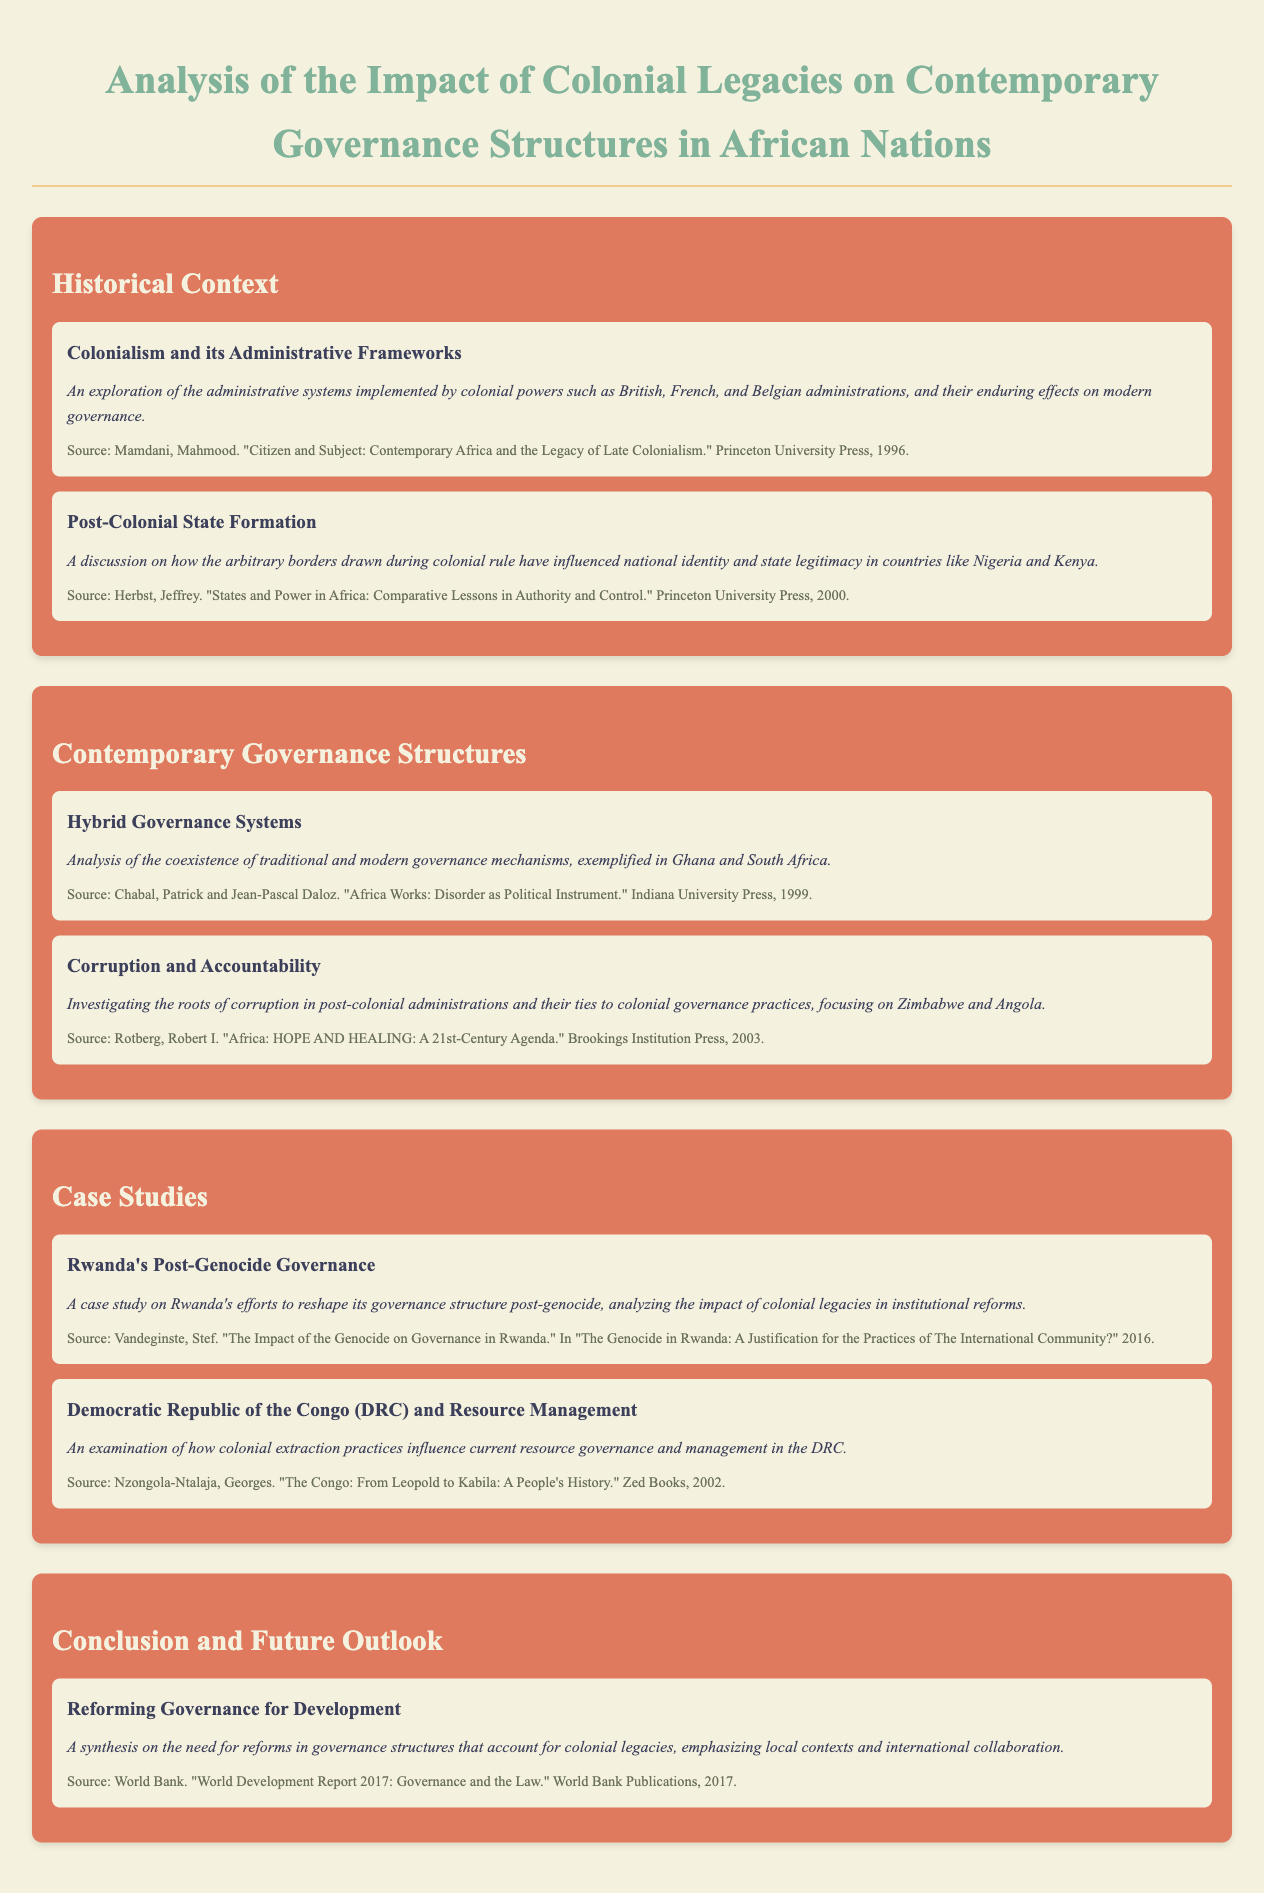What is the title of the document? The title appears prominently at the top of the document and is "Analysis of the Impact of Colonial Legacies on Contemporary Governance Structures in African Nations."
Answer: Analysis of the Impact of Colonial Legacies on Contemporary Governance Structures in African Nations Who authored "Citizen and Subject"? This work by Mahmood Mamdani discusses the enduring effects of colonial administrative systems.
Answer: Mahmood Mamdani Which country is specifically mentioned in the context of post-colonial state formation? The document discusses how arbitrary borders have influenced national identity in countries, specifically mentioning Nigeria and Kenya.
Answer: Nigeria and Kenya What is the main focus of the case study on Rwanda? The document details Rwanda's efforts to reshape governance post-genocide, analyzing colonial legacies in institutional reforms.
Answer: Rwanda's Post-Genocide Governance What type of governance systems are examined in Ghana and South Africa? The document analyzes the coexistence of traditional and modern governance mechanisms in these countries.
Answer: Hybrid Governance Systems What significant issue is linked to corruption in Zimbabwe and Angola? The document investigates the roots of corruption in post-colonial administrations and their connections to colonial governance practices.
Answer: Colonial governance practices What is a key need emphasized in the conclusion of the document? The document stresses the need for reforms in governance structures that account for colonial legacies.
Answer: Reforms in governance structures Which publication discusses the governance and law in the 21st century? The source referenced in the conclusion outlines governance needs and is the "World Development Report 2017."
Answer: World Development Report 2017 How many sections are in the document? The document contains four main sections that discuss various aspects of colonial legacies and governance.
Answer: Four sections 